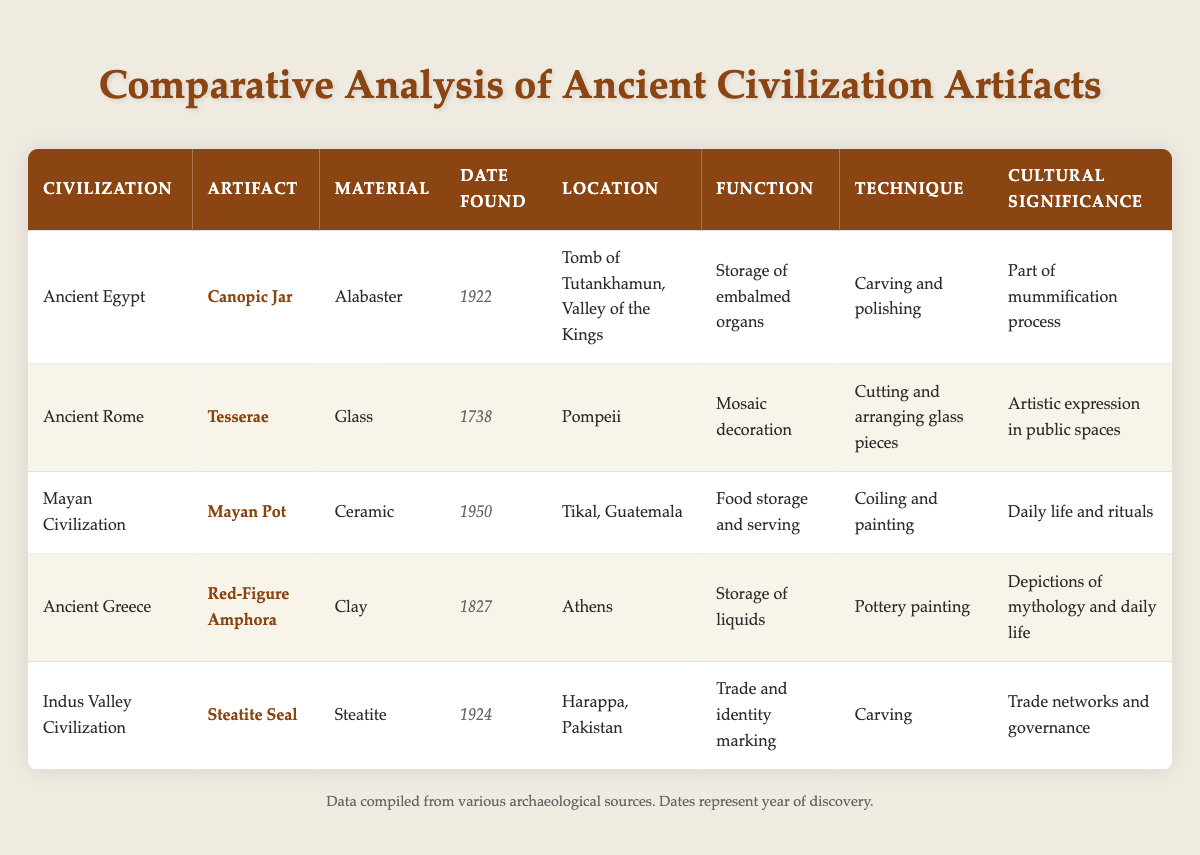What artifact was found in the Tomb of Tutankhamun? According to the table, the artifact found in the Tomb of Tutankhamun is the Canopic Jar. This information is found under the "Location" column corresponding to Ancient Egypt.
Answer: Canopic Jar Which civilization used ceramic as a material for their artifacts? The table lists the artifacts, and from the "Material" column, it shows that the Mayan Civilization used ceramic for their Mayan Pot.
Answer: Mayan Civilization Is the Red-Figure Amphora used for storage of liquids? Yes, the table states that the function of the Red-Figure Amphora is for the storage of liquids. This is indicated in the "Function" column under Ancient Greece.
Answer: Yes Which artifact was discovered first among the listed items? To determine this, we look at the "Date Found" column. The earliest artifact found is the Tesserae from Ancient Rome, discovered in 1738.
Answer: Tesserae What is the cultural significance of the Steatite Seal? The table indicates that the cultural significance of the Steatite Seal from the Indus Valley Civilization relates to trade networks and governance, as mentioned in the "Cultural Significance" column.
Answer: Trade networks and governance How many artifacts were found in the 1920s? We look at the "Date Found" column and find that two artifacts were found in the 1920s: the Canopic Jar (1922) and the Steatite Seal (1924). Therefore, the total count is 2.
Answer: 2 Which civilization has an artifact related to daily life and rituals? The Mayan Civilization is noted for the Mayan Pot, which is specifically identified as significant for daily life and rituals, according to the "Cultural Significance" column.
Answer: Mayan Civilization What materials were used to create the artifacts from Ancient Greece and Ancient Rome? In Ancient Greece, the Red-Figure Amphora is made of clay, while in Ancient Rome, the Tesserae is made of glass. Both materials are noted in their respective rows under the "Material" column.
Answer: Clay and Glass Did any artifacts have a function related to trade? Yes, the Steatite Seal from the Indus Valley Civilization is mentioned as having the function of trade and identity marking, as stated in the "Function" column.
Answer: Yes 